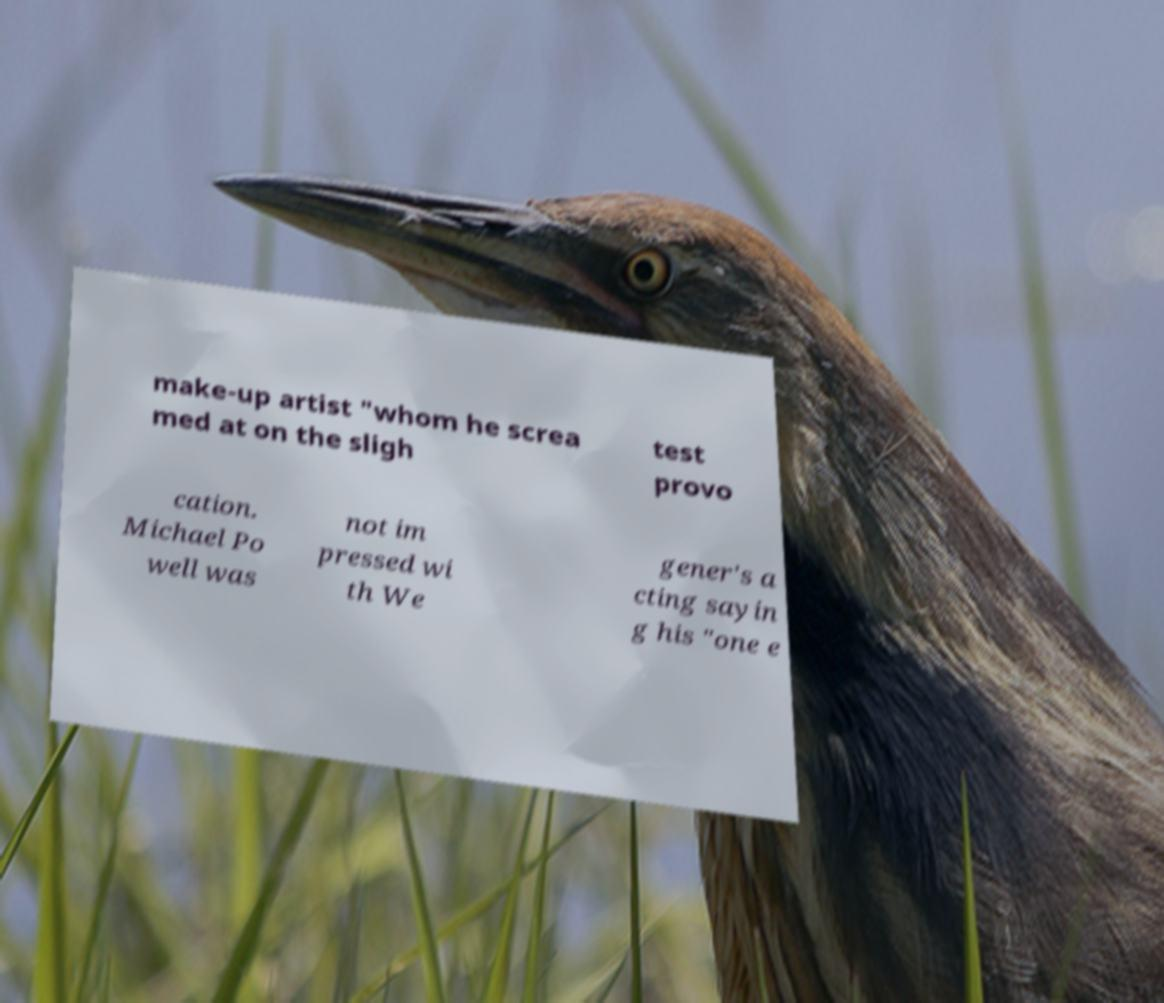Could you assist in decoding the text presented in this image and type it out clearly? make-up artist "whom he screa med at on the sligh test provo cation. Michael Po well was not im pressed wi th We gener's a cting sayin g his "one e 